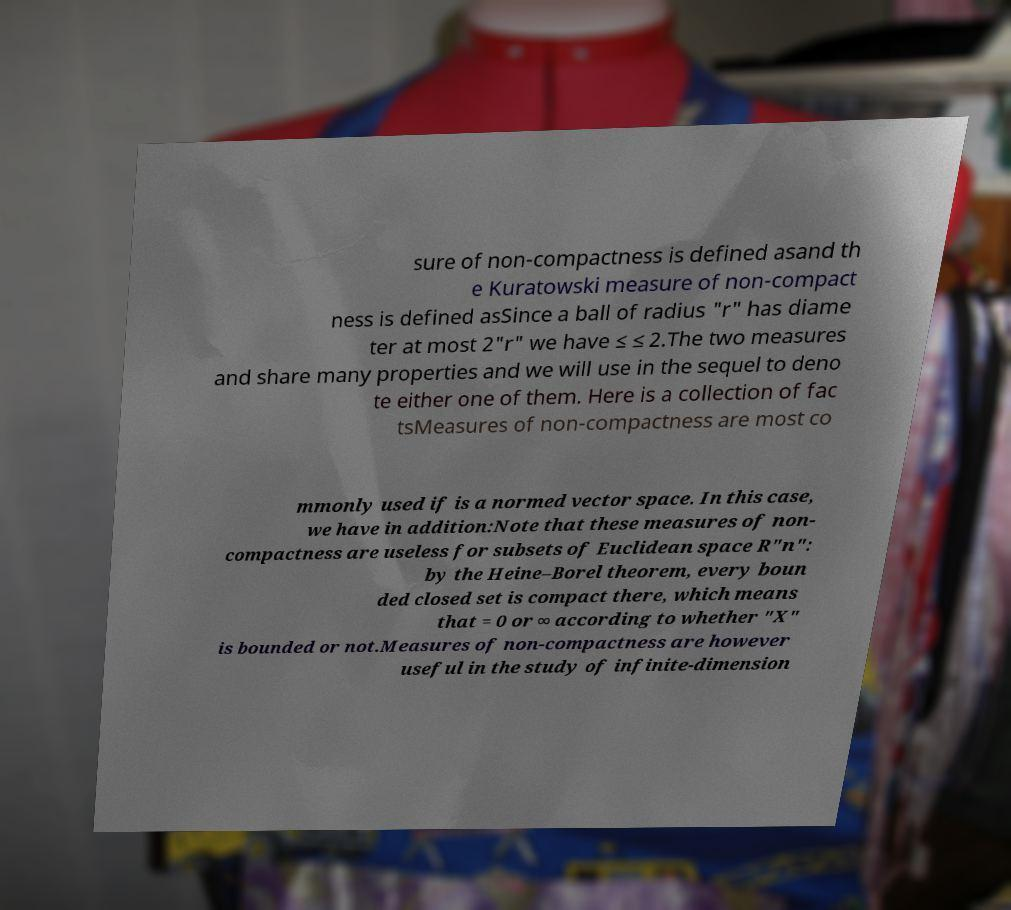For documentation purposes, I need the text within this image transcribed. Could you provide that? sure of non-compactness is defined asand th e Kuratowski measure of non-compact ness is defined asSince a ball of radius "r" has diame ter at most 2"r" we have ≤ ≤ 2.The two measures and share many properties and we will use in the sequel to deno te either one of them. Here is a collection of fac tsMeasures of non-compactness are most co mmonly used if is a normed vector space. In this case, we have in addition:Note that these measures of non- compactness are useless for subsets of Euclidean space R"n": by the Heine–Borel theorem, every boun ded closed set is compact there, which means that = 0 or ∞ according to whether "X" is bounded or not.Measures of non-compactness are however useful in the study of infinite-dimension 